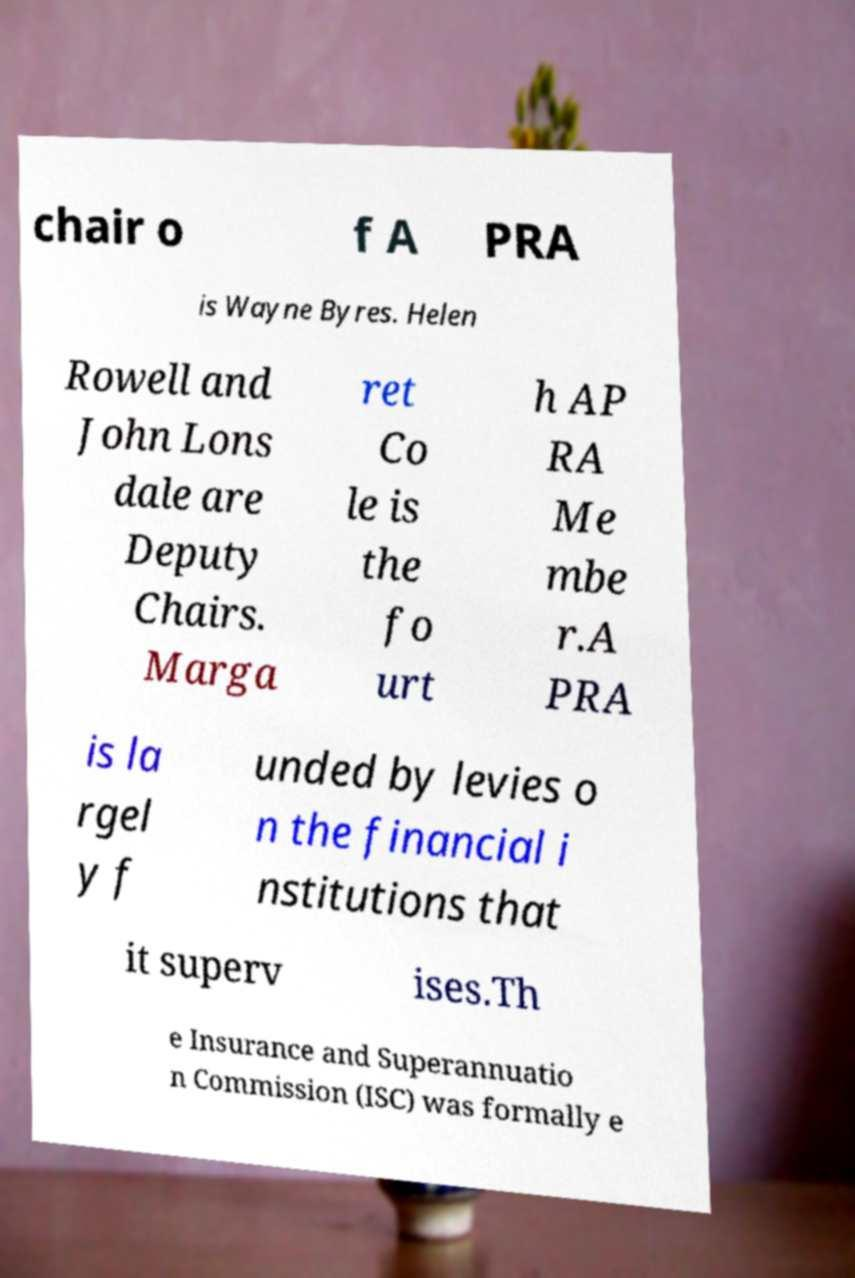What messages or text are displayed in this image? I need them in a readable, typed format. chair o f A PRA is Wayne Byres. Helen Rowell and John Lons dale are Deputy Chairs. Marga ret Co le is the fo urt h AP RA Me mbe r.A PRA is la rgel y f unded by levies o n the financial i nstitutions that it superv ises.Th e Insurance and Superannuatio n Commission (ISC) was formally e 